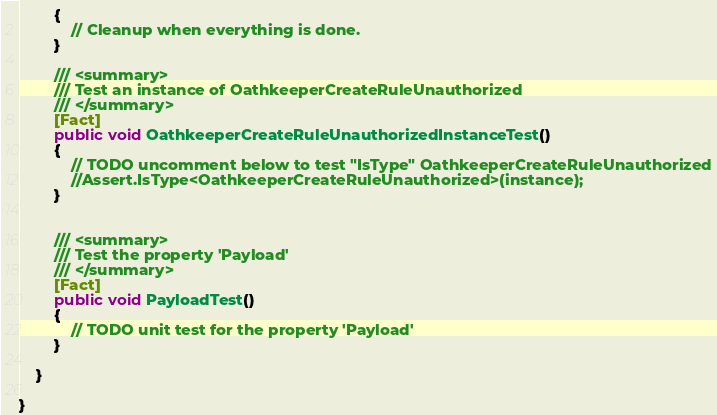Convert code to text. <code><loc_0><loc_0><loc_500><loc_500><_C#_>        {
            // Cleanup when everything is done.
        }

        /// <summary>
        /// Test an instance of OathkeeperCreateRuleUnauthorized
        /// </summary>
        [Fact]
        public void OathkeeperCreateRuleUnauthorizedInstanceTest()
        {
            // TODO uncomment below to test "IsType" OathkeeperCreateRuleUnauthorized
            //Assert.IsType<OathkeeperCreateRuleUnauthorized>(instance);
        }


        /// <summary>
        /// Test the property 'Payload'
        /// </summary>
        [Fact]
        public void PayloadTest()
        {
            // TODO unit test for the property 'Payload'
        }

    }

}
</code> 